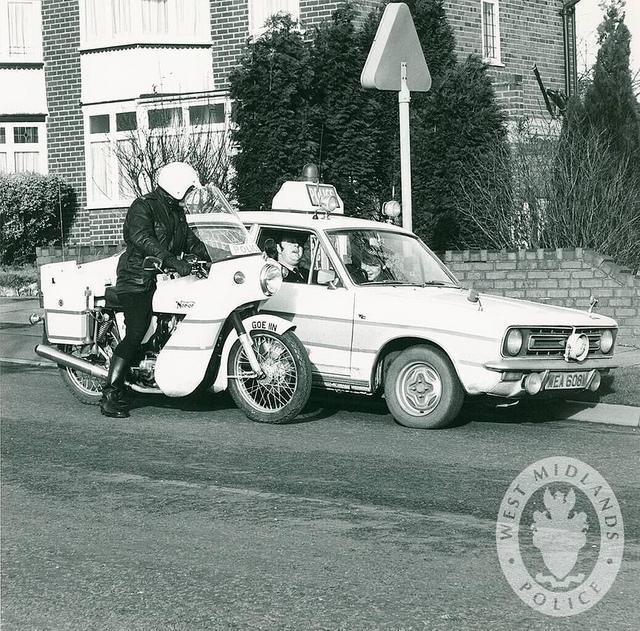How many helmets do you see?
Give a very brief answer. 1. How many people can you see?
Give a very brief answer. 1. How many bananas are there?
Give a very brief answer. 0. 